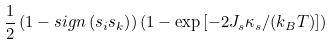Convert formula to latex. <formula><loc_0><loc_0><loc_500><loc_500>\frac { 1 } { 2 } \left ( 1 - s i g n \left ( s _ { i } s _ { k } \right ) \right ) \left ( 1 - \exp \left [ - 2 J _ { s } \kappa _ { s } / ( k _ { B } T ) \right ] \right )</formula> 